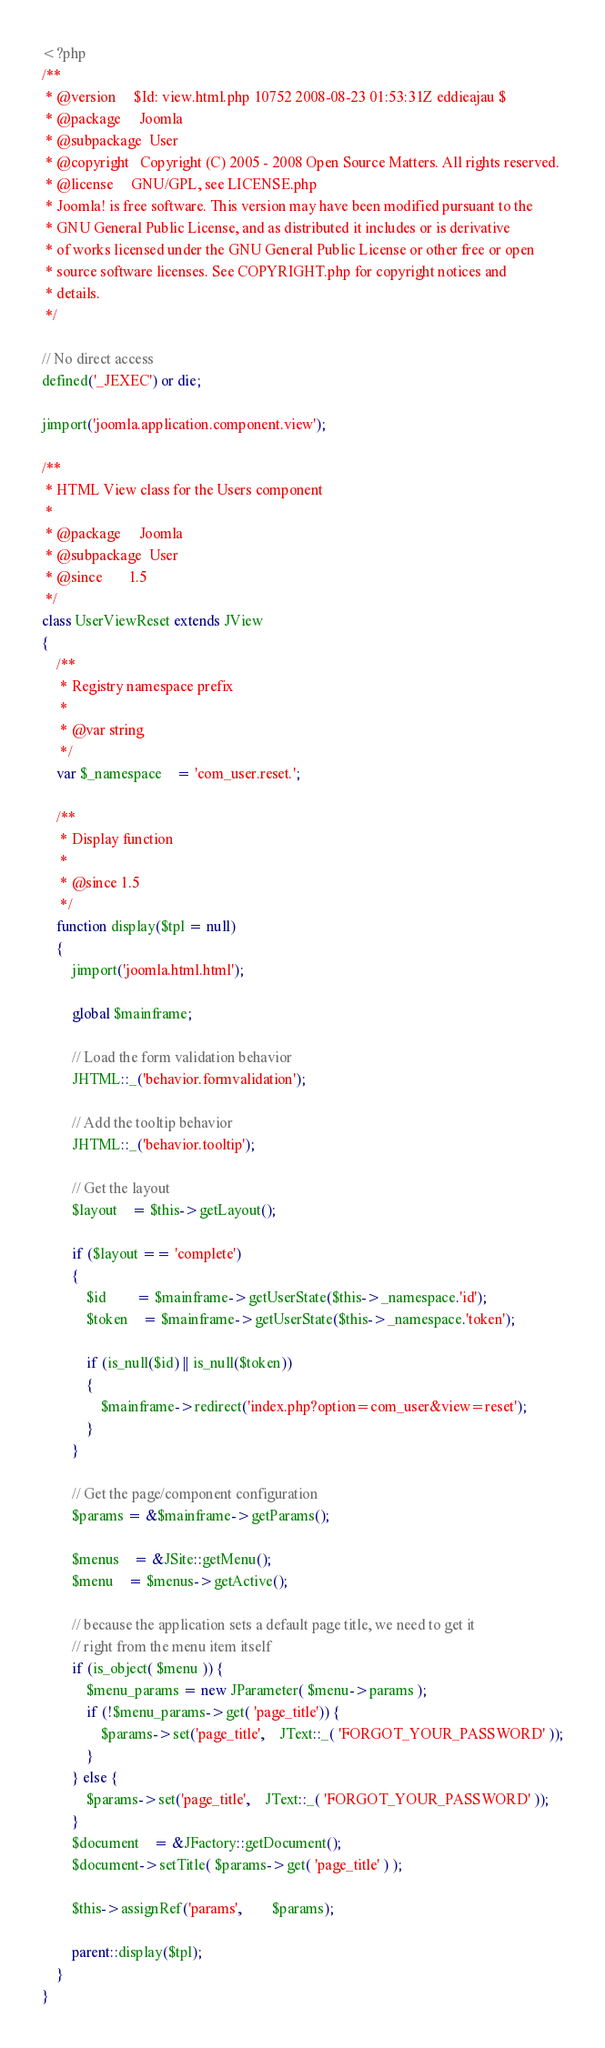<code> <loc_0><loc_0><loc_500><loc_500><_PHP_><?php
/**
 * @version		$Id: view.html.php 10752 2008-08-23 01:53:31Z eddieajau $
 * @package		Joomla
 * @subpackage	User
 * @copyright	Copyright (C) 2005 - 2008 Open Source Matters. All rights reserved.
 * @license		GNU/GPL, see LICENSE.php
 * Joomla! is free software. This version may have been modified pursuant to the
 * GNU General Public License, and as distributed it includes or is derivative
 * of works licensed under the GNU General Public License or other free or open
 * source software licenses. See COPYRIGHT.php for copyright notices and
 * details.
 */

// No direct access
defined('_JEXEC') or die;

jimport('joomla.application.component.view');

/**
 * HTML View class for the Users component
 *
 * @package		Joomla
 * @subpackage	User
 * @since		1.5
 */
class UserViewReset extends JView
{
	/**
	 * Registry namespace prefix
	 *
	 * @var	string
	 */
	var $_namespace	= 'com_user.reset.';

	/**
	 * Display function
	 *
	 * @since 1.5
	 */
	function display($tpl = null)
	{
		jimport('joomla.html.html');

		global $mainframe;

		// Load the form validation behavior
		JHTML::_('behavior.formvalidation');

		// Add the tooltip behavior
		JHTML::_('behavior.tooltip');

		// Get the layout
		$layout	= $this->getLayout();

		if ($layout == 'complete')
		{
			$id		= $mainframe->getUserState($this->_namespace.'id');
			$token	= $mainframe->getUserState($this->_namespace.'token');

			if (is_null($id) || is_null($token))
			{
				$mainframe->redirect('index.php?option=com_user&view=reset');
			}
		}

		// Get the page/component configuration
		$params = &$mainframe->getParams();

		$menus	= &JSite::getMenu();
		$menu	= $menus->getActive();

		// because the application sets a default page title, we need to get it
		// right from the menu item itself
		if (is_object( $menu )) {
			$menu_params = new JParameter( $menu->params );
			if (!$menu_params->get( 'page_title')) {
				$params->set('page_title',	JText::_( 'FORGOT_YOUR_PASSWORD' ));
			}
		} else {
			$params->set('page_title',	JText::_( 'FORGOT_YOUR_PASSWORD' ));
		}
		$document	= &JFactory::getDocument();
		$document->setTitle( $params->get( 'page_title' ) );

		$this->assignRef('params',		$params);

		parent::display($tpl);
	}
}
</code> 